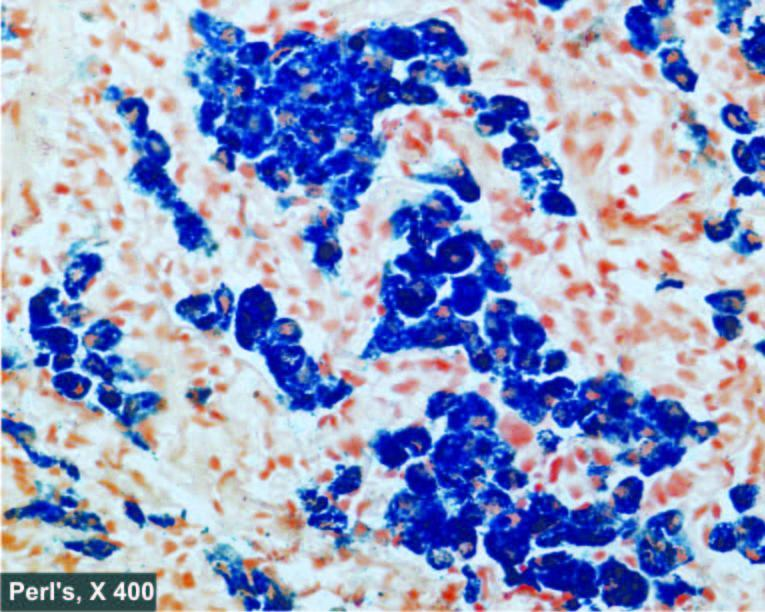re defects in any of the six see as prussian blue granules?
Answer the question using a single word or phrase. No 